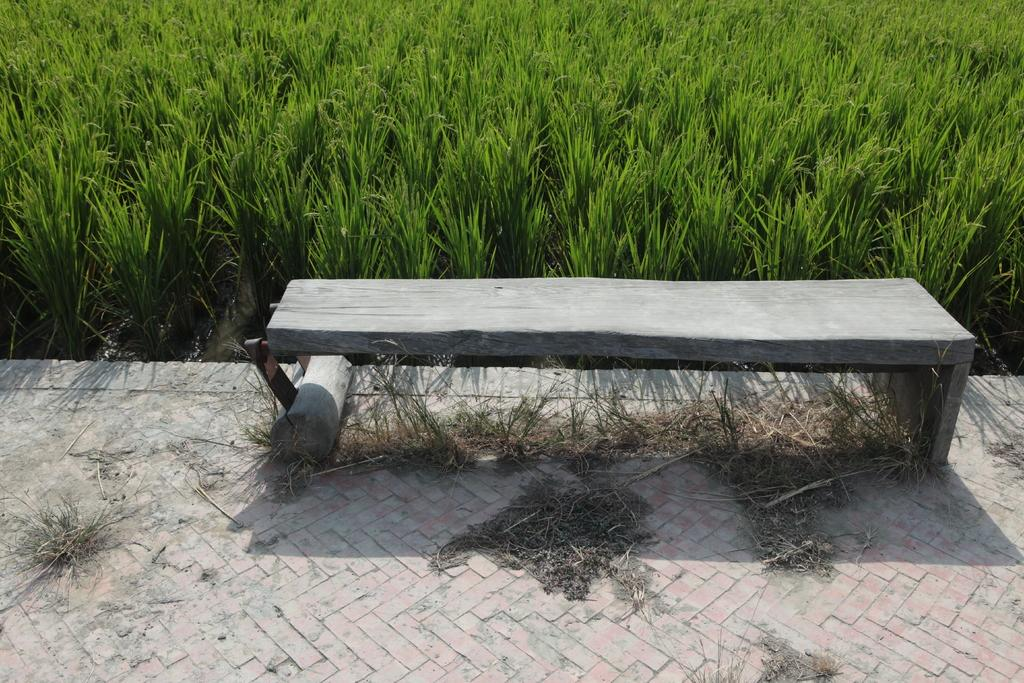What type of furniture is present in the image? There is a bench in the image. Where is the bench located? The bench is on the floor. What can be seen in the background of the image? There are plants in the background of the image. What is visible on the bench or floor? Dust is visible in the image. Are there any fairies sitting on the bench in the image? There are no fairies present in the image. What type of material is the bench made of, and does it have a knee-high backrest? The facts provided do not mention the material of the bench or its specific design features, such as a knee-high backrest. 